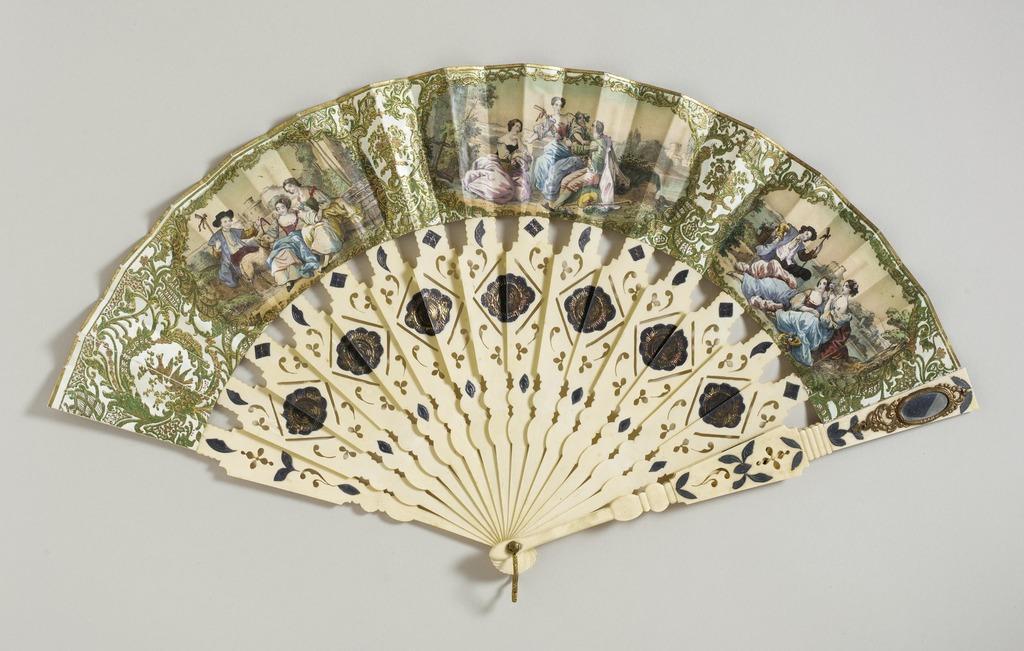Describe this image in one or two sentences. In this image we can see there are paintings of the persons, trees, water, sky and other designs on the hand fan which is placed on a surface. And the background is white in color. 